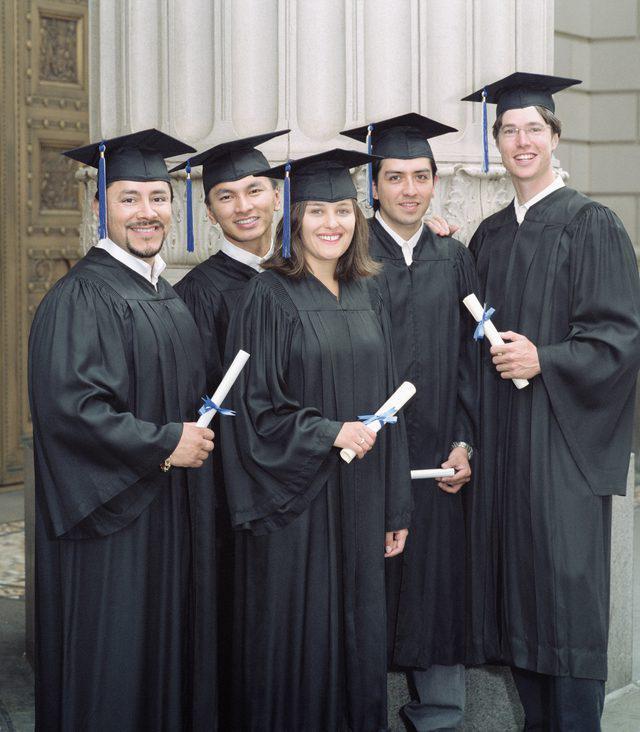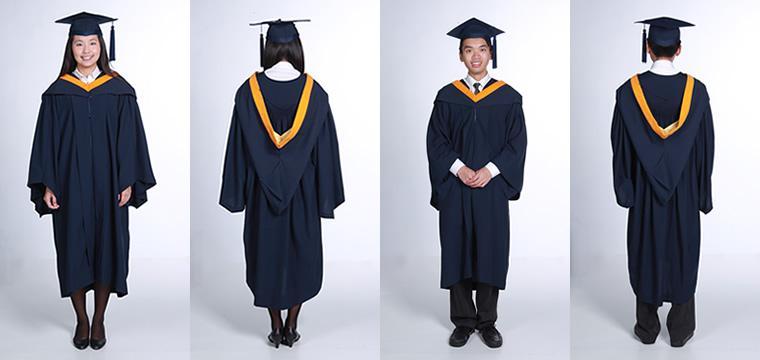The first image is the image on the left, the second image is the image on the right. Given the left and right images, does the statement "One image shows a row of all front-facing graduates in black robes, and none wear colored sashes." hold true? Answer yes or no. Yes. The first image is the image on the left, the second image is the image on the right. Analyze the images presented: Is the assertion "Three people are posing together in graduation attire in one of the images." valid? Answer yes or no. No. 